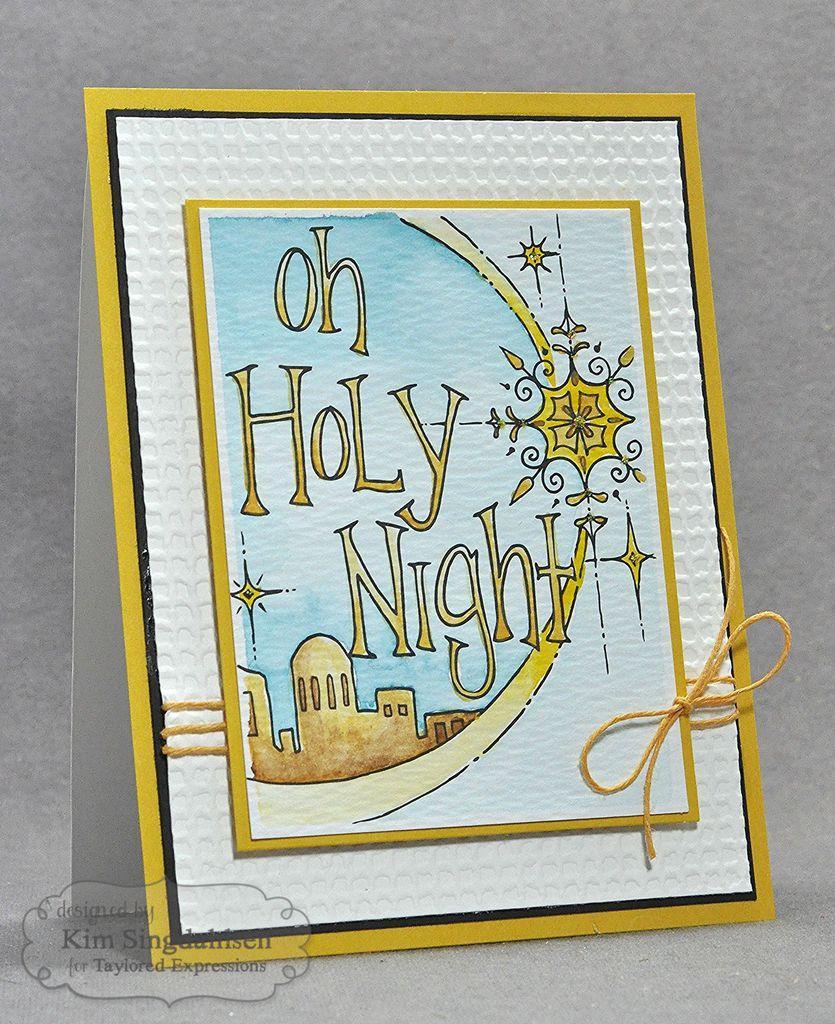Can you describe this image briefly? In this picture I can see a card with a thread, there is drawing on the card , and there is a watermark on the image. 